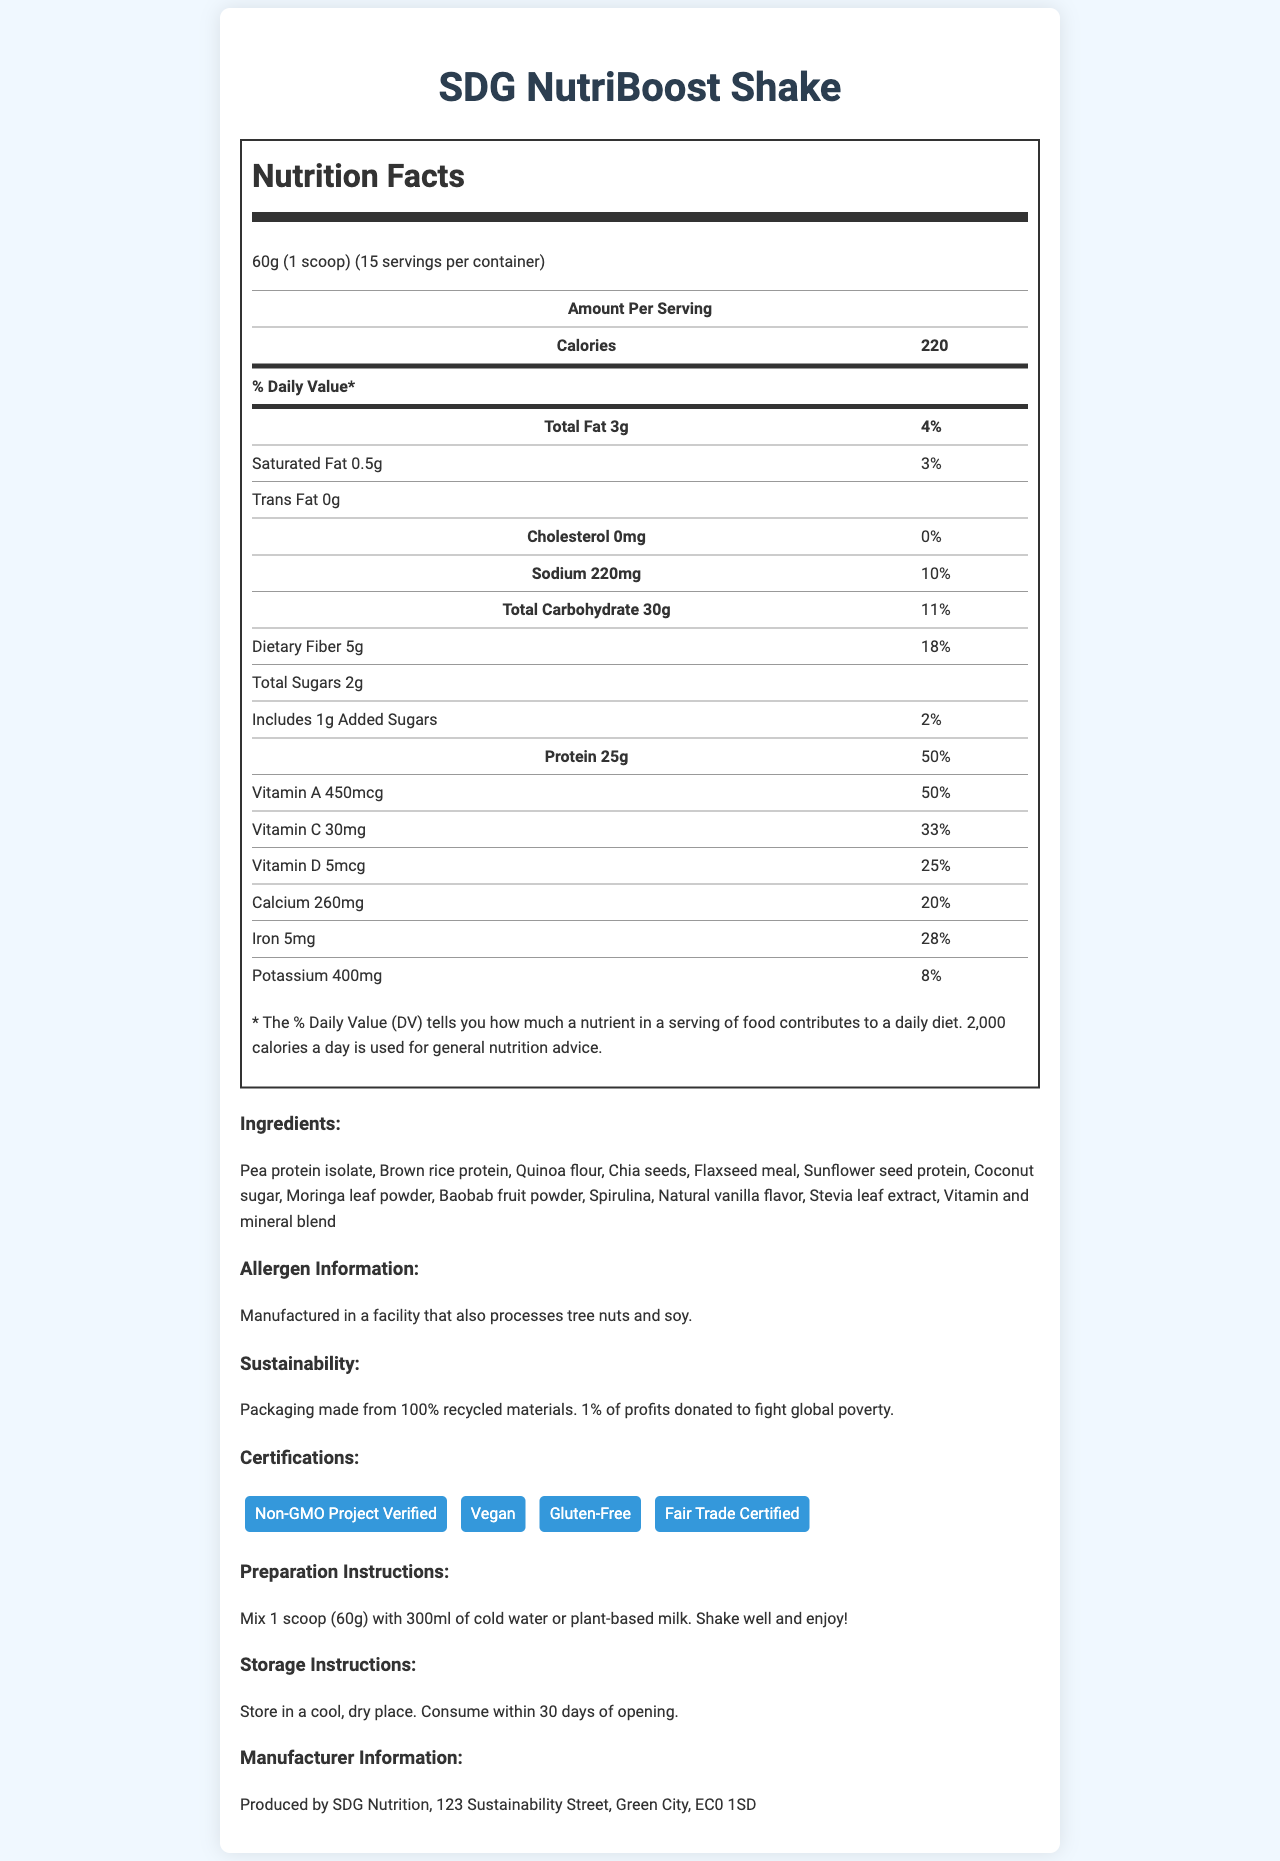what is the product name? The product name is clearly stated at the top of the document.
Answer: SDG NutriBoost Shake what is the serving size? The serving size is listed right under the product name as "60g (1 scoop)".
Answer: 60g (1 scoop) how many calories are in one serving? The calories are listed in the Amount Per Serving section as 220.
Answer: 220 what is the total fat content per serving? The total fat content per serving is listed under the Amount Per Serving section as "Total Fat 3g".
Answer: 3g how much dietary fiber does one serving provide? The dietary fiber content is listed under Total Carbohydrate in the Amount Per Serving section as "Dietary Fiber 5g".
Answer: 5g what percentage of the daily value does the protein content represent? The daily value percentage for protein is listed as "50%" in the Amount Per Serving section.
Answer: 50% which of the following certifications does the product have? A. USDA Organic B. Non-GMO Project Verified C. Kosher The document lists "Non-GMO Project Verified" as one of the certifications.
Answer: B what is the sodium content per serving? A. 150mg B. 200mg C. 220mg D. 250mg The sodium content per serving is listed as "Sodium 220mg".
Answer: C is the product gluten-free? The document lists "Gluten-Free" as one of the certifications, indicating the product is gluten-free.
Answer: Yes is there any cholesterol in the product? The document clearly lists the cholesterol amount as "0mg", indicating there is no cholesterol.
Answer: No describe the main benefits and features of the SDG NutriBoost Shake as stated in the document. The product is described as a nutritional and sustainable option with a focus on protein content and essential nutrients. The certifications verify its quality and inclusivity. Sustainable practices are highlighted by its packaging and profit donation to global poverty. Overall, it's designed for easy use and has clear preparation and storage instructions.
Answer: The SDG NutriBoost Shake is a low-cost, high-protein, plant-based meal replacement shake. It is rich in essential nutrients like protein, dietary fiber, vitamins, and minerals. The shake has sustainability features such as packaging made from 100% recycled materials and donating 1% of profits to fight global poverty. It has several certifications including Non-GMO Project Verified, Vegan, Gluten-Free, and Fair Trade Certified. The product is easy to prepare and has clear storage instructions. how many serving containers are included in one package? The document states there are 15 servings per container but does not specify the number of containers included in one package.
Answer: Cannot be determined what is the amount of Vitamin A provided per serving and its daily value percentage? The amount per serving and daily value percentage for Vitamin A are listed in the Amount Per Serving section as "Vitamin A 450mcg" and "50%" respectively.
Answer: 450mcg, 50% 